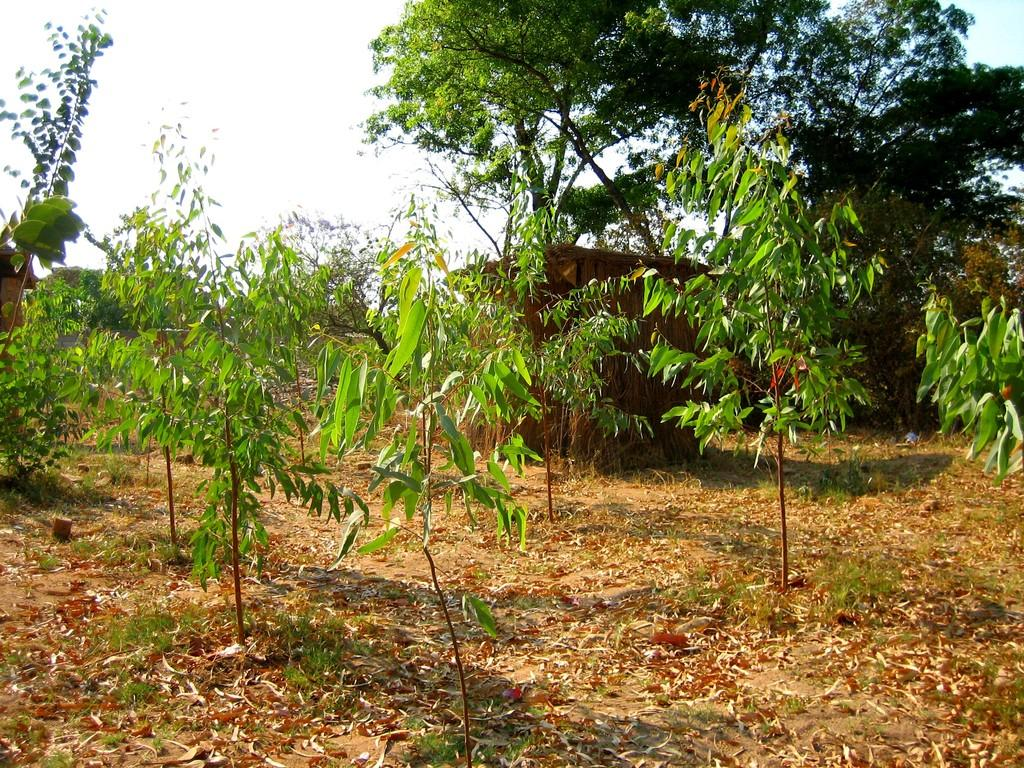What type of vegetation can be seen in the image? There are trees and plants in the image. What structure is located in the middle of the image? There is a hut in the middle of the image. What can be found on the ground in the image? Dry leaves are present on the land in the image. What type of belief is depicted in the image? There is no depiction of a belief in the image; it features trees, plants, a hut, and dry leaves. Can you tell me how many swings are present in the image? There are no swings present in the image. 